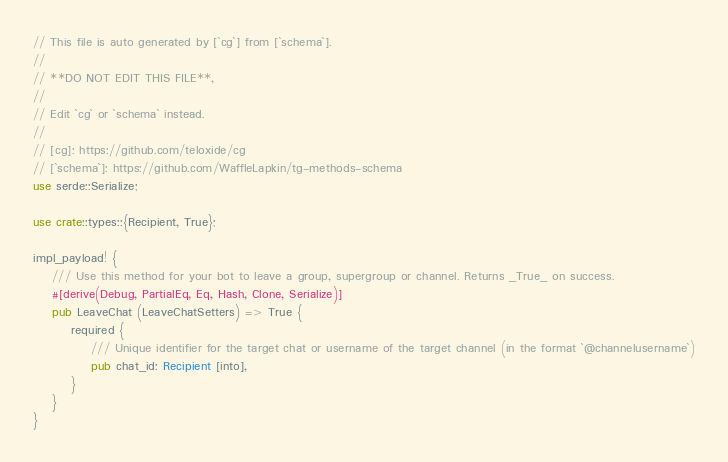Convert code to text. <code><loc_0><loc_0><loc_500><loc_500><_Rust_>// This file is auto generated by [`cg`] from [`schema`].
//
// **DO NOT EDIT THIS FILE**,
//
// Edit `cg` or `schema` instead.
//
// [cg]: https://github.com/teloxide/cg
// [`schema`]: https://github.com/WaffleLapkin/tg-methods-schema
use serde::Serialize;

use crate::types::{Recipient, True};

impl_payload! {
    /// Use this method for your bot to leave a group, supergroup or channel. Returns _True_ on success.
    #[derive(Debug, PartialEq, Eq, Hash, Clone, Serialize)]
    pub LeaveChat (LeaveChatSetters) => True {
        required {
            /// Unique identifier for the target chat or username of the target channel (in the format `@channelusername`)
            pub chat_id: Recipient [into],
        }
    }
}
</code> 